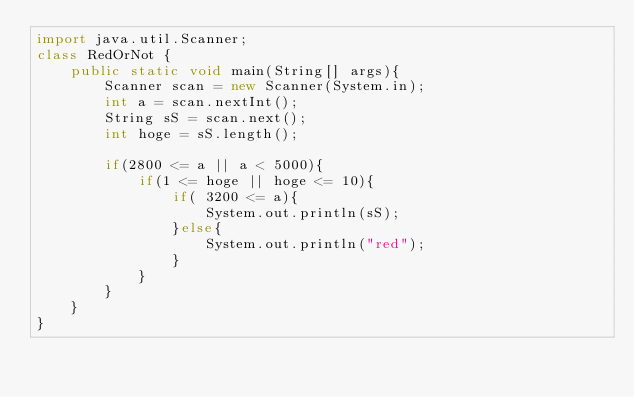Convert code to text. <code><loc_0><loc_0><loc_500><loc_500><_Java_>import java.util.Scanner;
class RedOrNot {
    public static void main(String[] args){
        Scanner scan = new Scanner(System.in);
        int a = scan.nextInt();
        String sS = scan.next();
        int hoge = sS.length();

        if(2800 <= a || a < 5000){
            if(1 <= hoge || hoge <= 10){
                if( 3200 <= a){
                    System.out.println(sS);
                }else{
                    System.out.println("red");
                }
            }
        }
    }
}</code> 